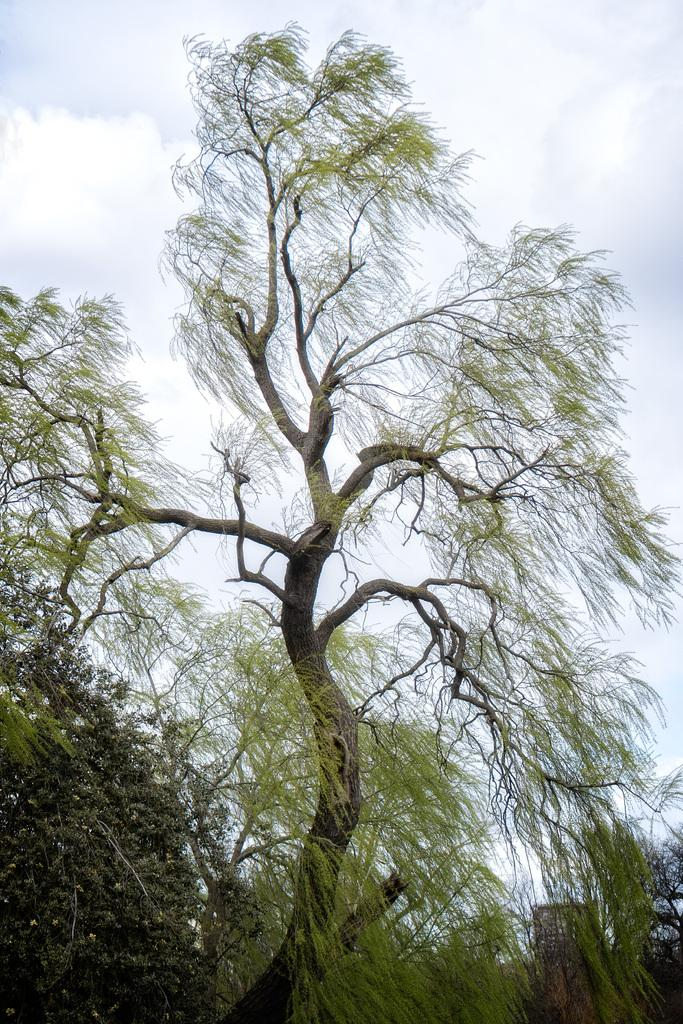What type of vegetation can be seen in the image? There are trees in the image. What is the color of the sky in the image? The sky is white in color. Are there any plants growing on the island in the image? There is no island present in the image, and therefore no plants growing on it. What type of pest can be seen crawling on the trees in the image? There are no pests visible on the trees in the image. 